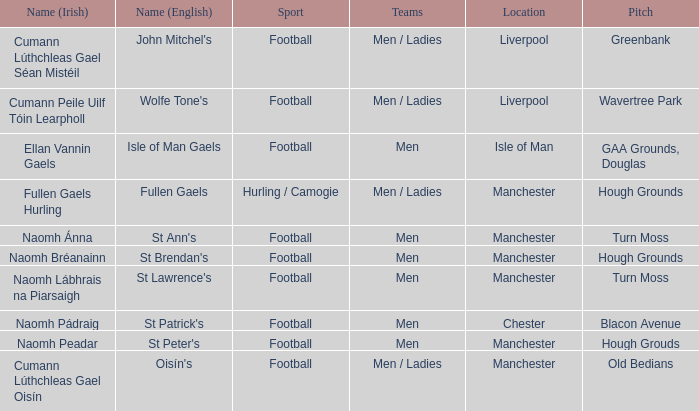What is the English Name of the Location in Chester? St Patrick's. 